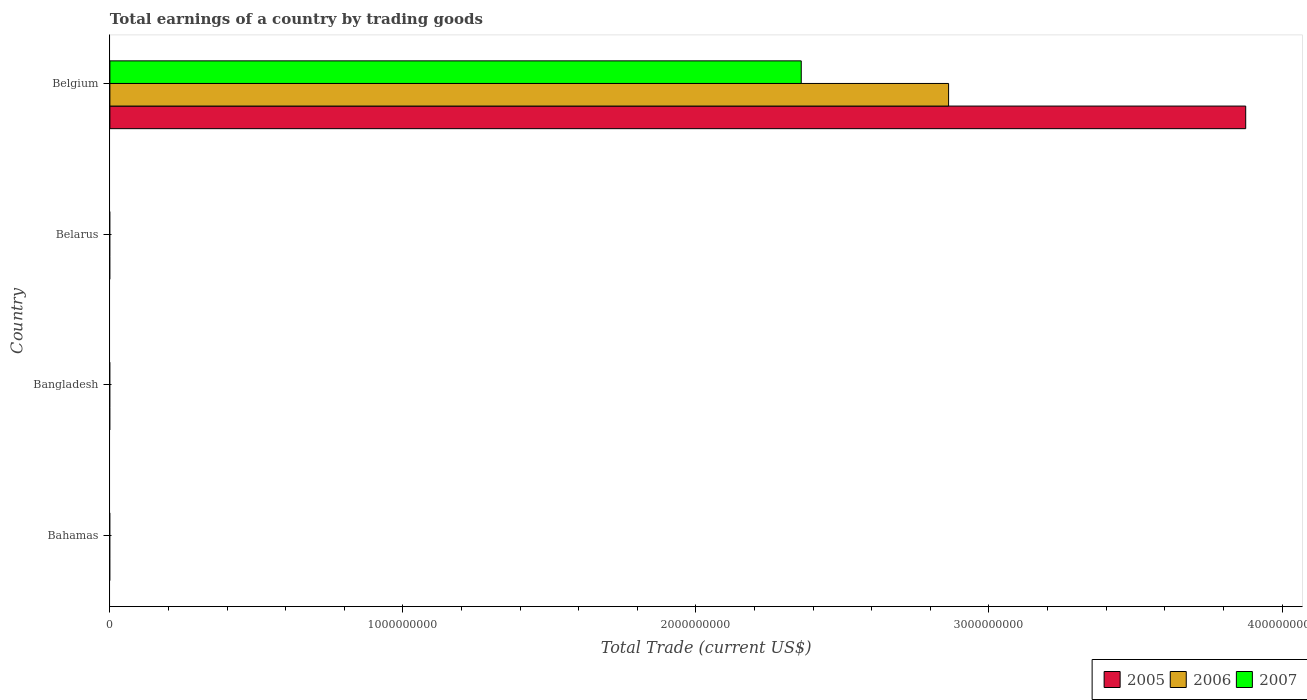How many different coloured bars are there?
Ensure brevity in your answer.  3. How many bars are there on the 3rd tick from the top?
Your answer should be very brief. 0. How many bars are there on the 3rd tick from the bottom?
Offer a very short reply. 0. What is the label of the 4th group of bars from the top?
Your answer should be very brief. Bahamas. In how many cases, is the number of bars for a given country not equal to the number of legend labels?
Your response must be concise. 3. Across all countries, what is the maximum total earnings in 2007?
Provide a succinct answer. 2.36e+09. What is the total total earnings in 2007 in the graph?
Offer a very short reply. 2.36e+09. What is the difference between the total earnings in 2005 in Bangladesh and the total earnings in 2007 in Belarus?
Keep it short and to the point. 0. What is the average total earnings in 2007 per country?
Provide a short and direct response. 5.90e+08. What is the difference between the total earnings in 2006 and total earnings in 2007 in Belgium?
Provide a short and direct response. 5.03e+08. What is the difference between the highest and the lowest total earnings in 2007?
Your answer should be very brief. 2.36e+09. Is it the case that in every country, the sum of the total earnings in 2007 and total earnings in 2005 is greater than the total earnings in 2006?
Provide a succinct answer. No. How many bars are there?
Make the answer very short. 3. Are all the bars in the graph horizontal?
Offer a terse response. Yes. What is the difference between two consecutive major ticks on the X-axis?
Ensure brevity in your answer.  1.00e+09. Does the graph contain any zero values?
Keep it short and to the point. Yes. How are the legend labels stacked?
Your response must be concise. Horizontal. What is the title of the graph?
Give a very brief answer. Total earnings of a country by trading goods. What is the label or title of the X-axis?
Offer a terse response. Total Trade (current US$). What is the Total Trade (current US$) of 2005 in Bahamas?
Make the answer very short. 0. What is the Total Trade (current US$) of 2006 in Bangladesh?
Offer a terse response. 0. What is the Total Trade (current US$) in 2005 in Belarus?
Your answer should be compact. 0. What is the Total Trade (current US$) of 2007 in Belarus?
Make the answer very short. 0. What is the Total Trade (current US$) of 2005 in Belgium?
Offer a terse response. 3.88e+09. What is the Total Trade (current US$) in 2006 in Belgium?
Offer a very short reply. 2.86e+09. What is the Total Trade (current US$) in 2007 in Belgium?
Make the answer very short. 2.36e+09. Across all countries, what is the maximum Total Trade (current US$) of 2005?
Ensure brevity in your answer.  3.88e+09. Across all countries, what is the maximum Total Trade (current US$) in 2006?
Your response must be concise. 2.86e+09. Across all countries, what is the maximum Total Trade (current US$) in 2007?
Provide a short and direct response. 2.36e+09. Across all countries, what is the minimum Total Trade (current US$) of 2006?
Make the answer very short. 0. What is the total Total Trade (current US$) of 2005 in the graph?
Keep it short and to the point. 3.88e+09. What is the total Total Trade (current US$) in 2006 in the graph?
Provide a short and direct response. 2.86e+09. What is the total Total Trade (current US$) of 2007 in the graph?
Keep it short and to the point. 2.36e+09. What is the average Total Trade (current US$) in 2005 per country?
Your answer should be very brief. 9.69e+08. What is the average Total Trade (current US$) of 2006 per country?
Give a very brief answer. 7.16e+08. What is the average Total Trade (current US$) in 2007 per country?
Make the answer very short. 5.90e+08. What is the difference between the Total Trade (current US$) of 2005 and Total Trade (current US$) of 2006 in Belgium?
Offer a very short reply. 1.01e+09. What is the difference between the Total Trade (current US$) in 2005 and Total Trade (current US$) in 2007 in Belgium?
Your response must be concise. 1.52e+09. What is the difference between the Total Trade (current US$) in 2006 and Total Trade (current US$) in 2007 in Belgium?
Provide a short and direct response. 5.03e+08. What is the difference between the highest and the lowest Total Trade (current US$) in 2005?
Your answer should be very brief. 3.88e+09. What is the difference between the highest and the lowest Total Trade (current US$) of 2006?
Your answer should be compact. 2.86e+09. What is the difference between the highest and the lowest Total Trade (current US$) of 2007?
Make the answer very short. 2.36e+09. 